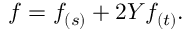Convert formula to latex. <formula><loc_0><loc_0><loc_500><loc_500>f = f _ { ( s ) } + 2 Y f _ { ( t ) } .</formula> 